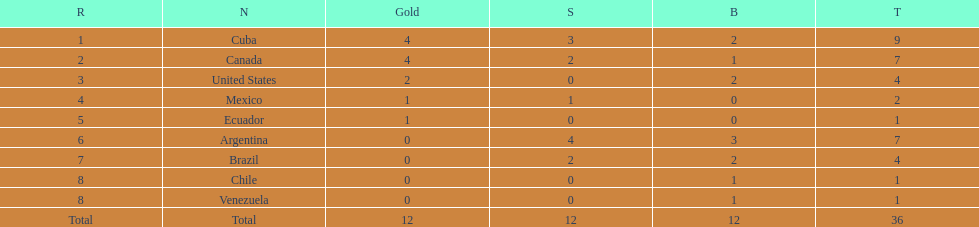Which country secured the gold medal but failed to obtain silver? United States. 